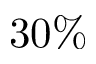Convert formula to latex. <formula><loc_0><loc_0><loc_500><loc_500>3 0 \%</formula> 